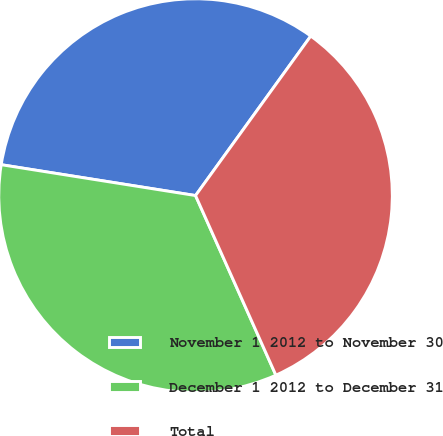Convert chart to OTSL. <chart><loc_0><loc_0><loc_500><loc_500><pie_chart><fcel>November 1 2012 to November 30<fcel>December 1 2012 to December 31<fcel>Total<nl><fcel>32.45%<fcel>34.2%<fcel>33.35%<nl></chart> 